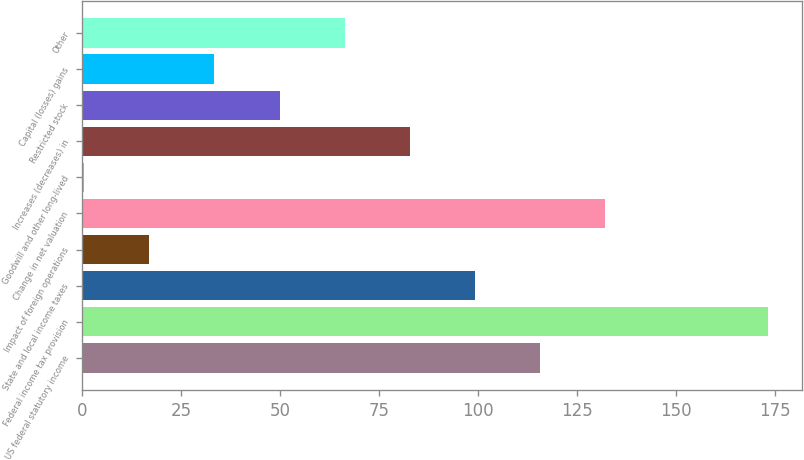Convert chart to OTSL. <chart><loc_0><loc_0><loc_500><loc_500><bar_chart><fcel>US federal statutory income<fcel>Federal income tax provision<fcel>State and local income taxes<fcel>Impact of foreign operations<fcel>Change in net valuation<fcel>Goodwill and other long-lived<fcel>Increases (decreases) in<fcel>Restricted stock<fcel>Capital (losses) gains<fcel>Other<nl><fcel>115.62<fcel>173.06<fcel>99.16<fcel>16.86<fcel>132.08<fcel>0.4<fcel>82.7<fcel>49.78<fcel>33.32<fcel>66.24<nl></chart> 